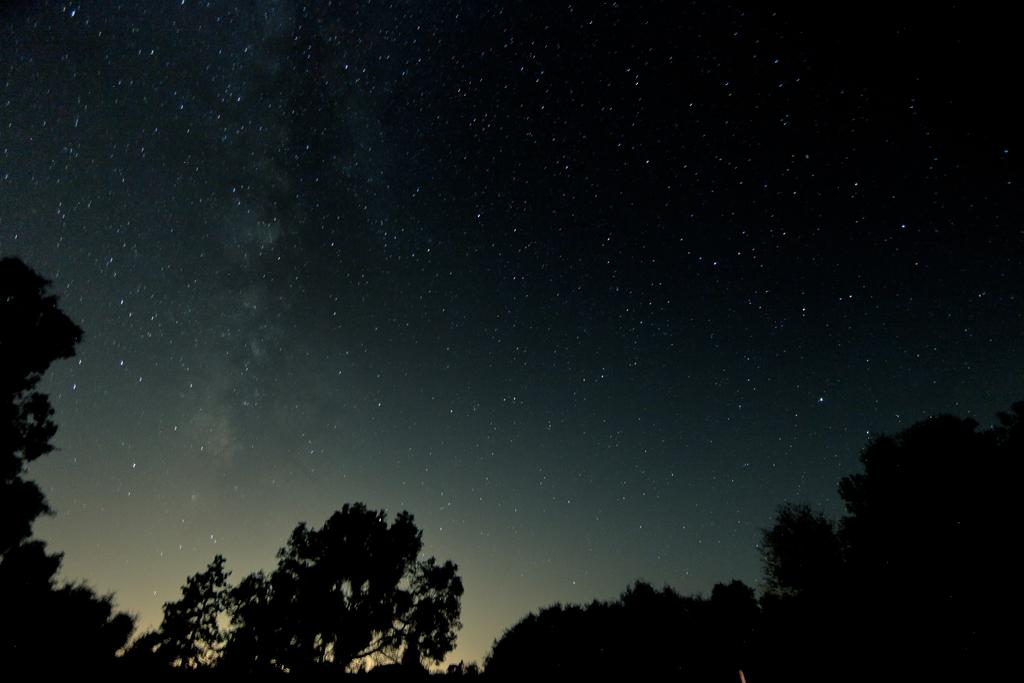What type of vegetation can be seen in the image? There are trees in the image. How would you describe the sky in the background of the image? The sky in the background has black, blue, and white colors. Is there a church visible in the image? No, there is no church present in the image. Can you see anyone swimming in the image? No, there is no swimming or any body of water visible in the image. 